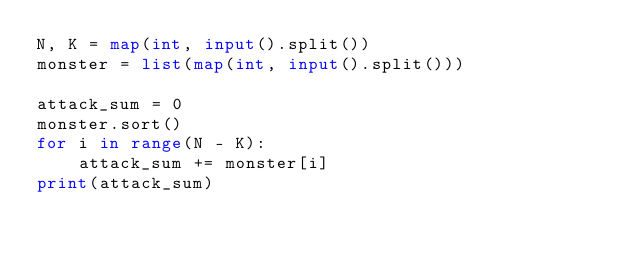Convert code to text. <code><loc_0><loc_0><loc_500><loc_500><_Python_>N, K = map(int, input().split())
monster = list(map(int, input().split()))

attack_sum = 0
monster.sort()
for i in range(N - K):
    attack_sum += monster[i]
print(attack_sum)</code> 